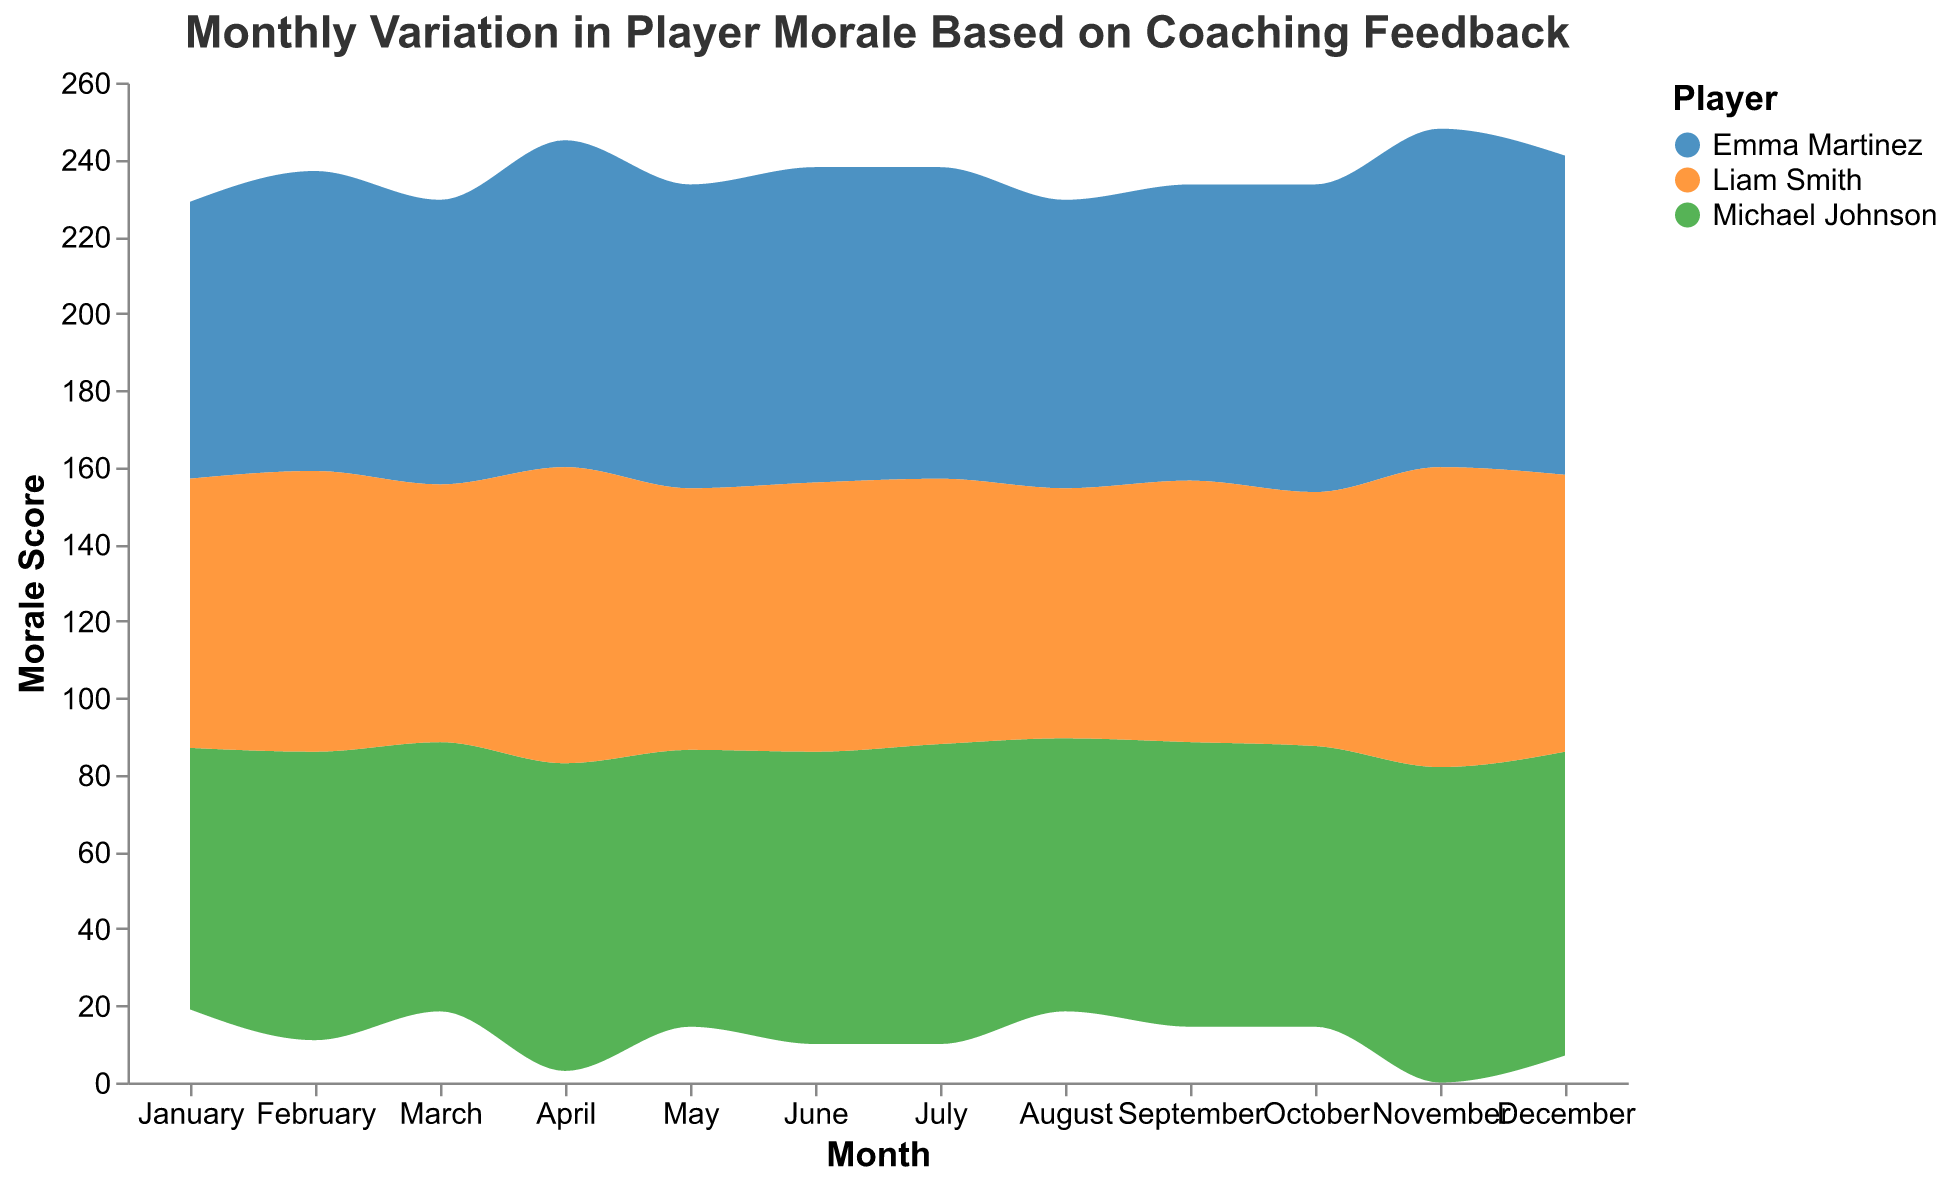What is the title of the graph? The title of the graph is located at the top of the figure and it reads "Monthly Variation in Player Morale Based on Coaching Feedback".
Answer: Monthly Variation in Player Morale Based on Coaching Feedback How many players' morale scores are depicted in the graph? The legend on the right side of the graph shows the three different colors representing three players: Michael Johnson, Emma Martinez, and Liam Smith.
Answer: 3 In which month does Emma Martinez have the highest morale score? By observing the data associated with the different months, Emma Martinez's highest morale score occurs in November.
Answer: November What is Liam Smith's average morale score from January to December? To find the average, sum Liam Smith's morale scores for each month and divide by 12. The sum is (70 + 73 + 67 + 77 + 68 + 70 + 69 + 65 + 68 + 66 + 78 + 72) = 843. Thus, the average is 843 / 12 = 70.25.
Answer: 70.25 Which player had the largest increase in morale score from January to April? Calculate the difference in morale between January and April for each player. Michael Johnson: 80 - 68 = 12, Emma Martinez: 85 - 72 = 13, Liam Smith: 77 - 70 = 7. Emma Martinez has the largest increase.
Answer: Emma Martinez How does Michael Johnson's morale score change from September to October? The morale scores are observed to change from 74 in September to 73 in October, indicating a decrease.
Answer: Decrease Who had the lowest morale score in August? By comparing the players' values in August, Liam Smith has the lowest morale score of 65.
Answer: Liam Smith What's the total morale score for all players in the month of May? Sum the morale scores of all players in May: Michael Johnson (72), Emma Martinez (79), and Liam Smith (68). The total is 72 + 79 + 68 = 219.
Answer: 219 Which player experienced the most fluctuations in their morale scores over the year? By observing the overall variation in the heights of the colored areas corresponding to each player, Emma Martinez shows the most significant ups and downs depicting the highest fluctuations.
Answer: Emma Martinez 